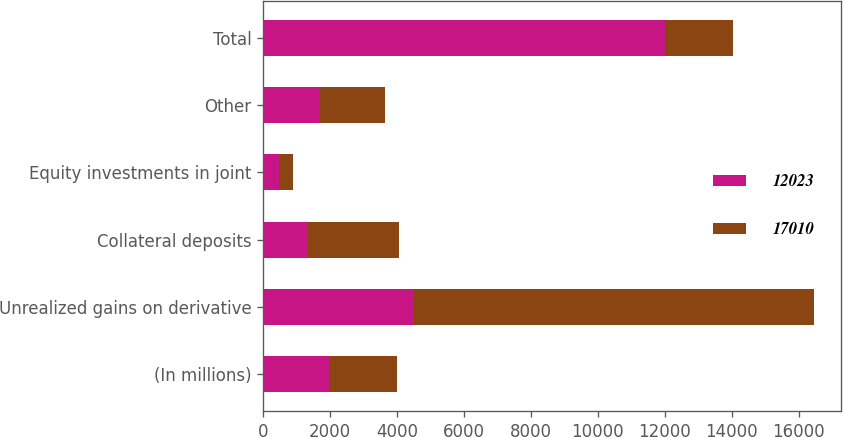<chart> <loc_0><loc_0><loc_500><loc_500><stacked_bar_chart><ecel><fcel>(In millions)<fcel>Unrealized gains on derivative<fcel>Collateral deposits<fcel>Equity investments in joint<fcel>Other<fcel>Total<nl><fcel>12023<fcel>2009<fcel>4511<fcel>1351<fcel>492<fcel>1696<fcel>12023<nl><fcel>17010<fcel>2008<fcel>11943<fcel>2709<fcel>412<fcel>1946<fcel>2008<nl></chart> 